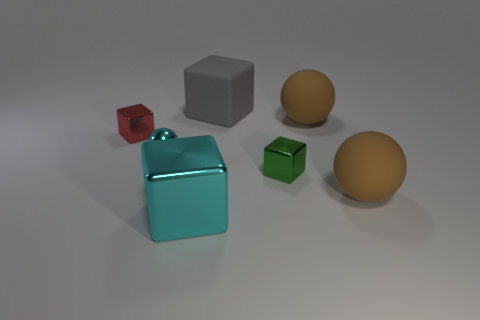Add 1 big matte balls. How many objects exist? 8 Subtract all cyan spheres. How many spheres are left? 2 Subtract all gray blocks. How many blocks are left? 3 Subtract all cubes. How many objects are left? 3 Subtract 3 blocks. How many blocks are left? 1 Subtract all cyan cubes. Subtract all purple cylinders. How many cubes are left? 3 Subtract all yellow spheres. How many red cubes are left? 1 Subtract all big brown matte blocks. Subtract all cubes. How many objects are left? 3 Add 6 large metal blocks. How many large metal blocks are left? 7 Add 7 tiny cyan balls. How many tiny cyan balls exist? 8 